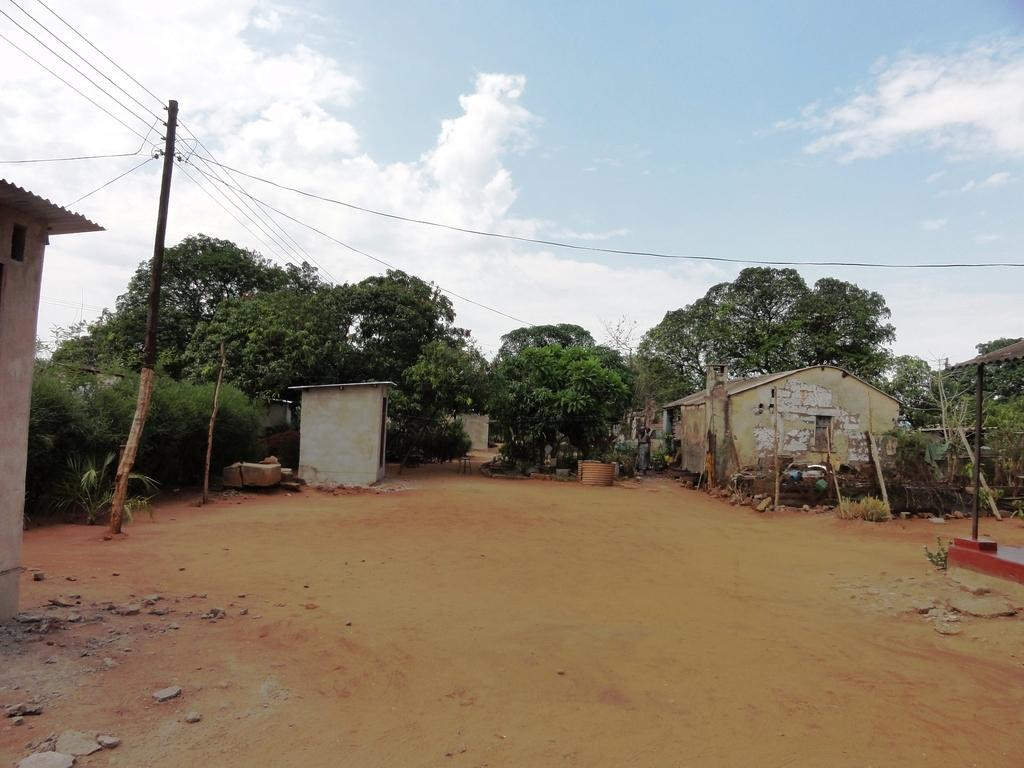What type of structures can be seen in the image? There are sheds in the image. What other natural elements are present in the image? There are trees in the image. What man-made objects can be seen in the image? There are poles with wires in the image. What type of terrain is visible at the bottom of the image? There are stones visible at the bottom of the image. What is the ground like in the image? There is ground visible in the image. What can be seen in the sky at the top of the image? There are clouds in the sky at the top of the image. What type of leaf is on the head of the person in the image? There is no person present in the image, so there is no head or leaf to be found. How is the division between the sheds and trees organized in the image? The image does not depict any divisions between the sheds and trees; they are simply present in the scene. 